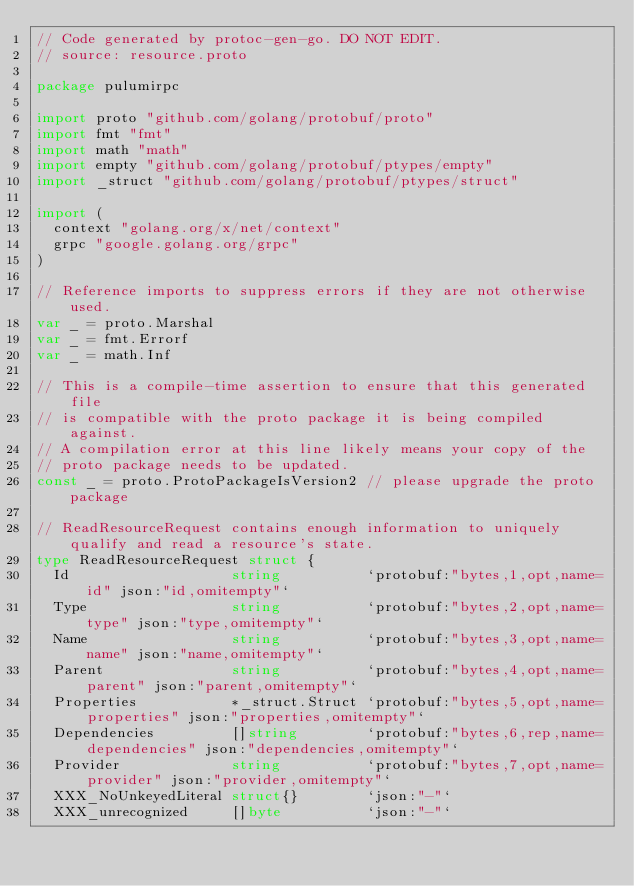<code> <loc_0><loc_0><loc_500><loc_500><_Go_>// Code generated by protoc-gen-go. DO NOT EDIT.
// source: resource.proto

package pulumirpc

import proto "github.com/golang/protobuf/proto"
import fmt "fmt"
import math "math"
import empty "github.com/golang/protobuf/ptypes/empty"
import _struct "github.com/golang/protobuf/ptypes/struct"

import (
	context "golang.org/x/net/context"
	grpc "google.golang.org/grpc"
)

// Reference imports to suppress errors if they are not otherwise used.
var _ = proto.Marshal
var _ = fmt.Errorf
var _ = math.Inf

// This is a compile-time assertion to ensure that this generated file
// is compatible with the proto package it is being compiled against.
// A compilation error at this line likely means your copy of the
// proto package needs to be updated.
const _ = proto.ProtoPackageIsVersion2 // please upgrade the proto package

// ReadResourceRequest contains enough information to uniquely qualify and read a resource's state.
type ReadResourceRequest struct {
	Id                   string          `protobuf:"bytes,1,opt,name=id" json:"id,omitempty"`
	Type                 string          `protobuf:"bytes,2,opt,name=type" json:"type,omitempty"`
	Name                 string          `protobuf:"bytes,3,opt,name=name" json:"name,omitempty"`
	Parent               string          `protobuf:"bytes,4,opt,name=parent" json:"parent,omitempty"`
	Properties           *_struct.Struct `protobuf:"bytes,5,opt,name=properties" json:"properties,omitempty"`
	Dependencies         []string        `protobuf:"bytes,6,rep,name=dependencies" json:"dependencies,omitempty"`
	Provider             string          `protobuf:"bytes,7,opt,name=provider" json:"provider,omitempty"`
	XXX_NoUnkeyedLiteral struct{}        `json:"-"`
	XXX_unrecognized     []byte          `json:"-"`</code> 